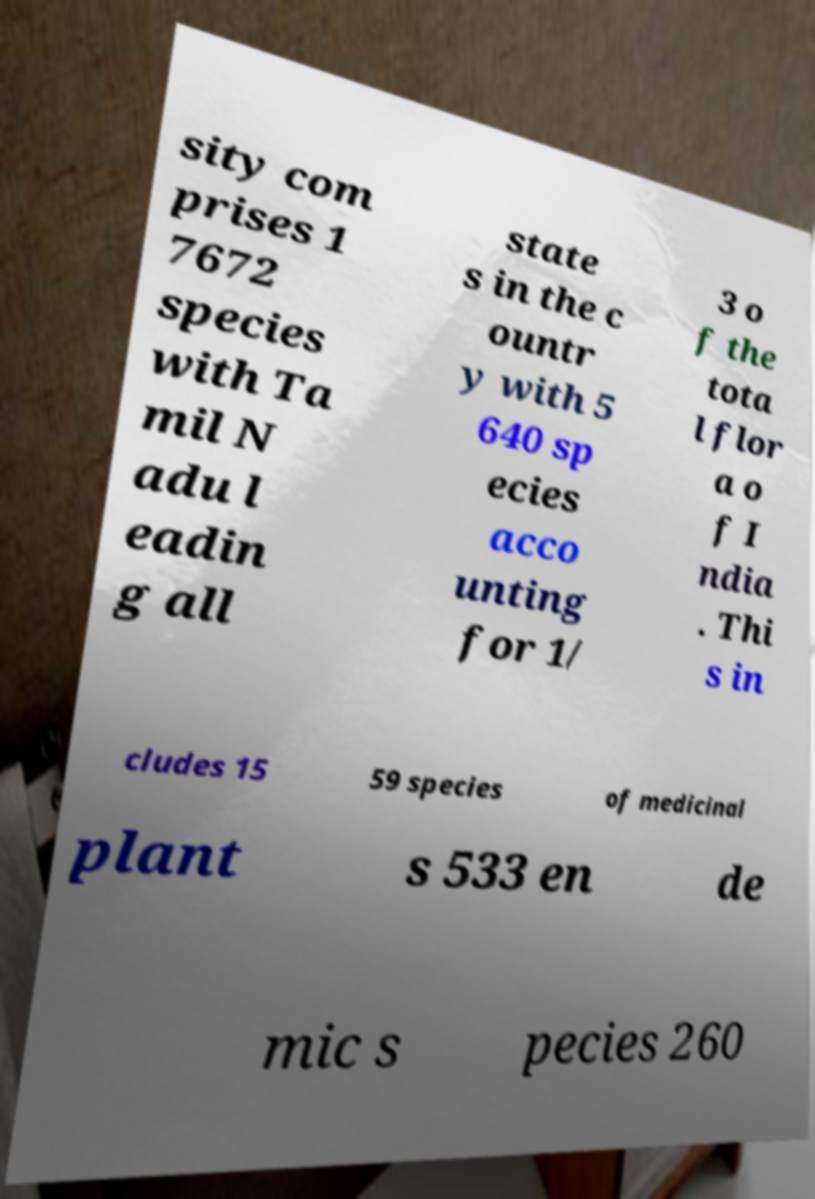Can you accurately transcribe the text from the provided image for me? sity com prises 1 7672 species with Ta mil N adu l eadin g all state s in the c ountr y with 5 640 sp ecies acco unting for 1/ 3 o f the tota l flor a o f I ndia . Thi s in cludes 15 59 species of medicinal plant s 533 en de mic s pecies 260 